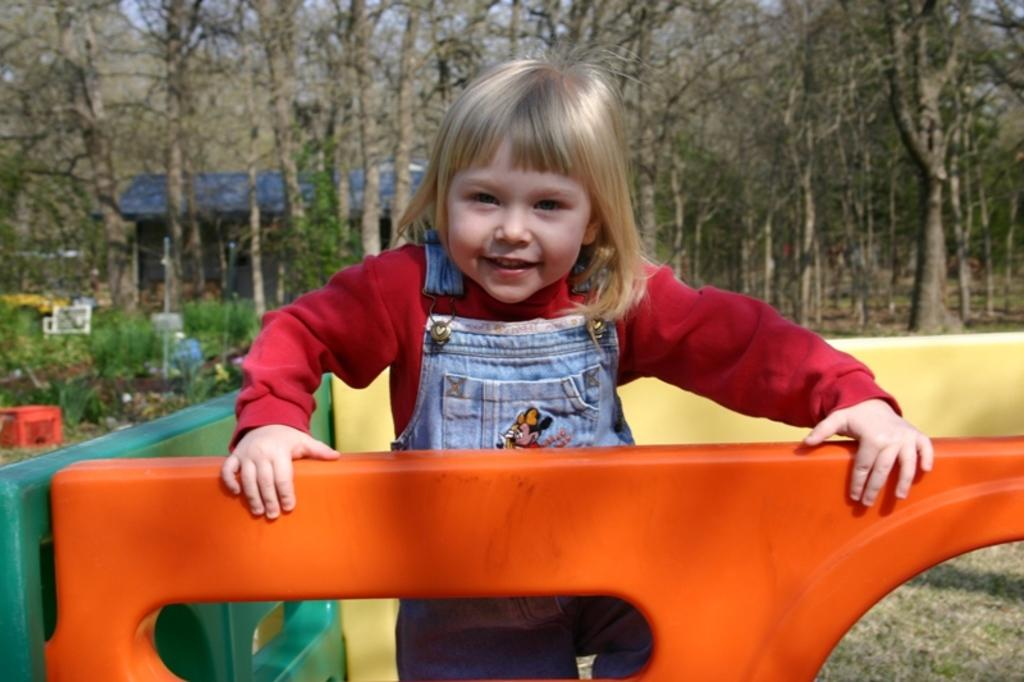What is the main subject of the image? The main subject of the image is a small girl. What is the girl wearing in the image? The girl is wearing a red t-shirt and a denim jacket. What is the girl doing in the image? The girl is playing in the ground. What can be seen in the background of the image? There are dry trees and a blue-colored house in the background of the image. What type of shoe is the girl wearing in the image? The facts provided do not mention any shoes worn by the girl in the image. --- 